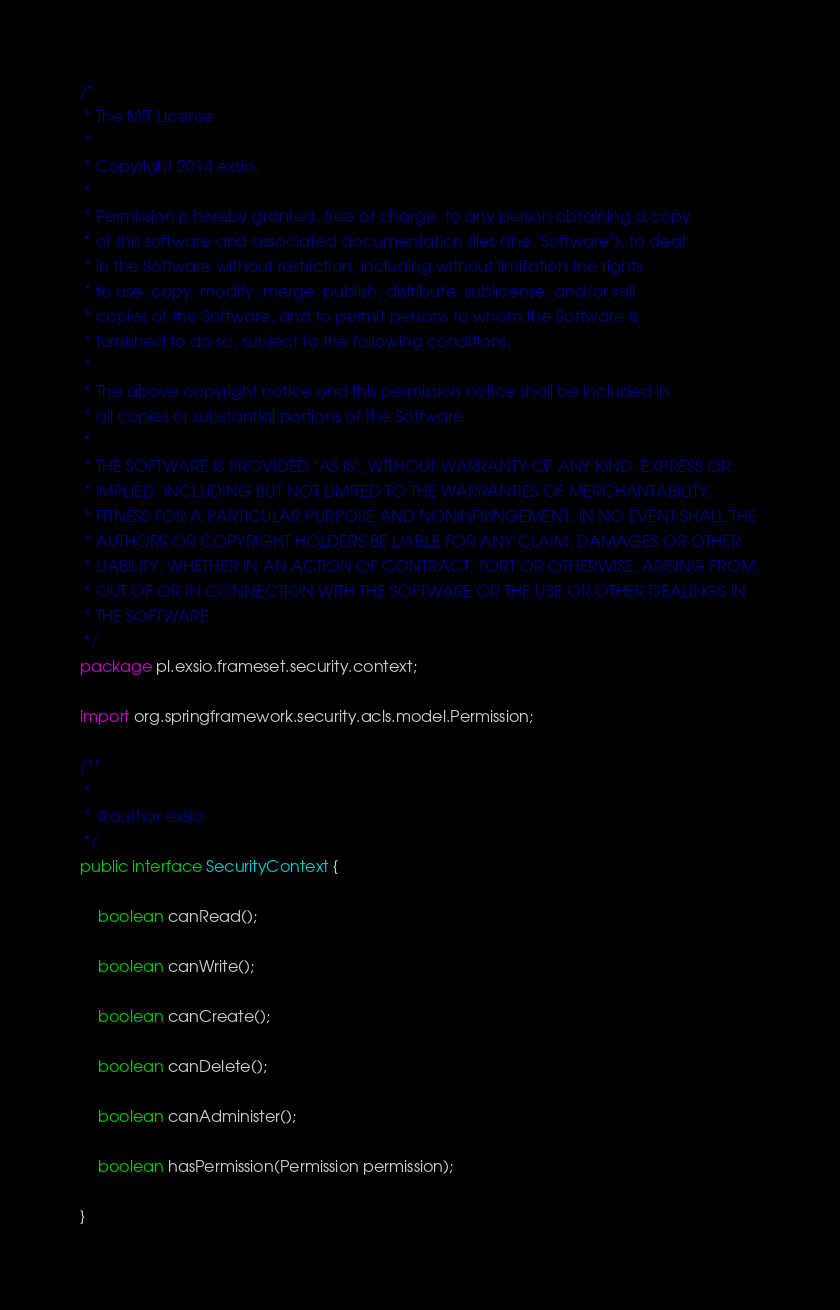<code> <loc_0><loc_0><loc_500><loc_500><_Java_>/* 
 * The MIT License
 *
 * Copyright 2014 exsio.
 *
 * Permission is hereby granted, free of charge, to any person obtaining a copy
 * of this software and associated documentation files (the "Software"), to deal
 * in the Software without restriction, including without limitation the rights
 * to use, copy, modify, merge, publish, distribute, sublicense, and/or sell
 * copies of the Software, and to permit persons to whom the Software is
 * furnished to do so, subject to the following conditions:
 *
 * The above copyright notice and this permission notice shall be included in
 * all copies or substantial portions of the Software.
 *
 * THE SOFTWARE IS PROVIDED "AS IS", WITHOUT WARRANTY OF ANY KIND, EXPRESS OR
 * IMPLIED, INCLUDING BUT NOT LIMITED TO THE WARRANTIES OF MERCHANTABILITY,
 * FITNESS FOR A PARTICULAR PURPOSE AND NONINFRINGEMENT. IN NO EVENT SHALL THE
 * AUTHORS OR COPYRIGHT HOLDERS BE LIABLE FOR ANY CLAIM, DAMAGES OR OTHER
 * LIABILITY, WHETHER IN AN ACTION OF CONTRACT, TORT OR OTHERWISE, ARISING FROM,
 * OUT OF OR IN CONNECTION WITH THE SOFTWARE OR THE USE OR OTHER DEALINGS IN
 * THE SOFTWARE.
 */
package pl.exsio.frameset.security.context;

import org.springframework.security.acls.model.Permission;

/**
 *
 * @author exsio
 */
public interface SecurityContext {
    
    boolean canRead();
    
    boolean canWrite();
    
    boolean canCreate();
    
    boolean canDelete();
    
    boolean canAdminister();
    
    boolean hasPermission(Permission permission);
    
}
</code> 